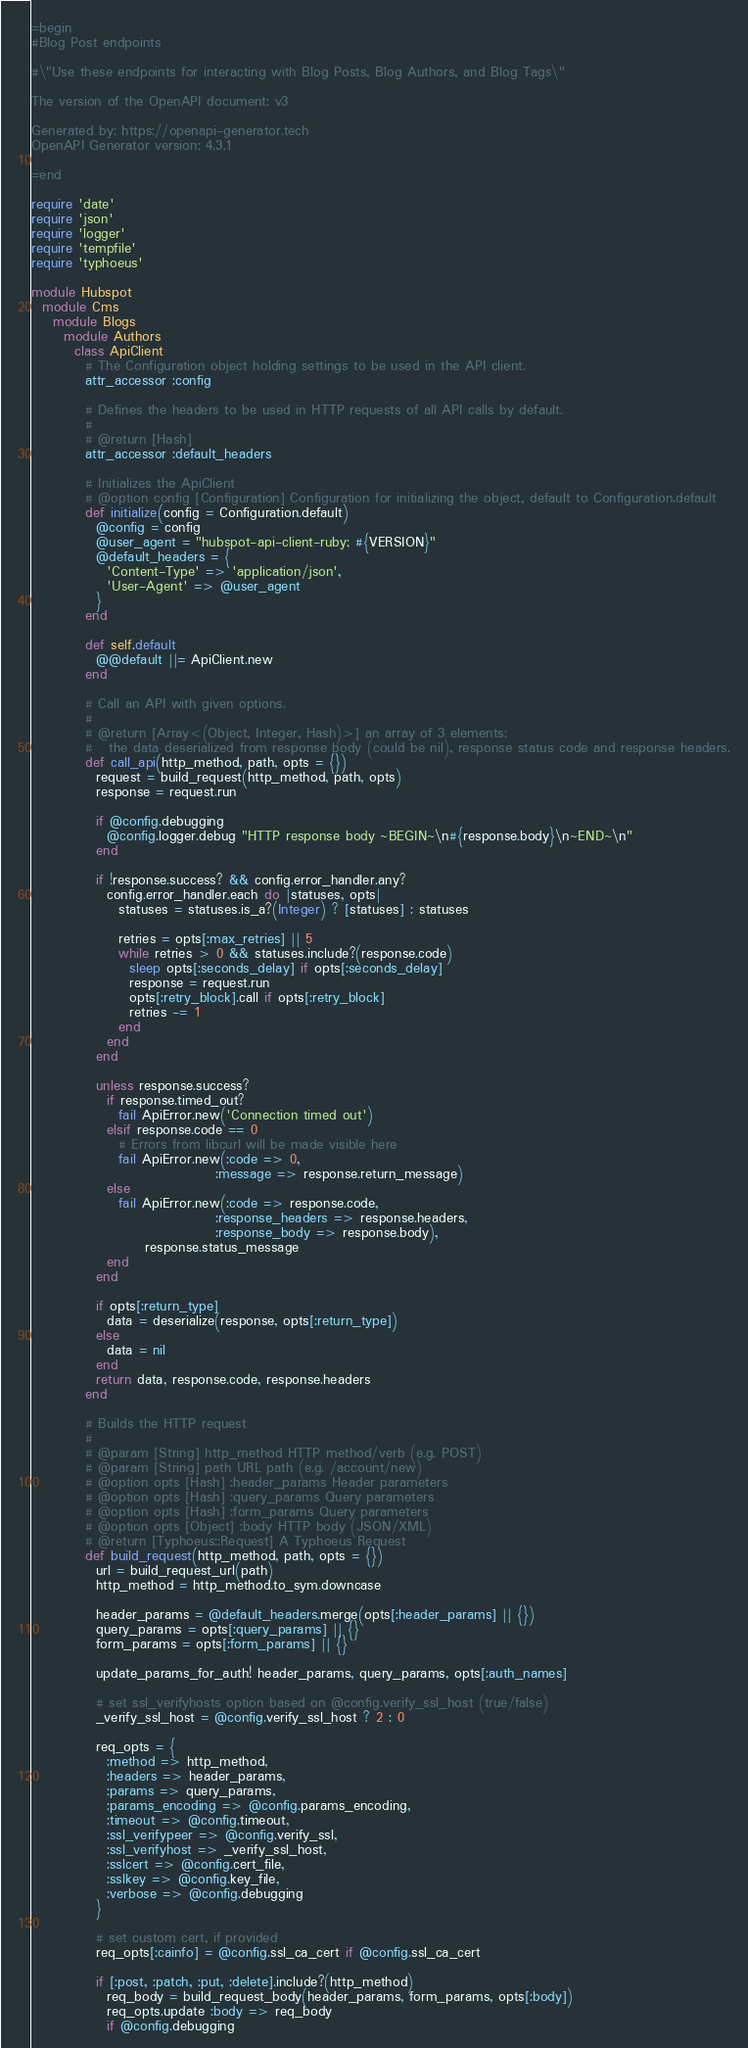<code> <loc_0><loc_0><loc_500><loc_500><_Ruby_>=begin
#Blog Post endpoints

#\"Use these endpoints for interacting with Blog Posts, Blog Authors, and Blog Tags\"

The version of the OpenAPI document: v3

Generated by: https://openapi-generator.tech
OpenAPI Generator version: 4.3.1

=end

require 'date'
require 'json'
require 'logger'
require 'tempfile'
require 'typhoeus'

module Hubspot
  module Cms
    module Blogs
      module Authors
        class ApiClient
          # The Configuration object holding settings to be used in the API client.
          attr_accessor :config

          # Defines the headers to be used in HTTP requests of all API calls by default.
          #
          # @return [Hash]
          attr_accessor :default_headers

          # Initializes the ApiClient
          # @option config [Configuration] Configuration for initializing the object, default to Configuration.default
          def initialize(config = Configuration.default)
            @config = config
            @user_agent = "hubspot-api-client-ruby; #{VERSION}"
            @default_headers = {
              'Content-Type' => 'application/json',
              'User-Agent' => @user_agent
            }
          end

          def self.default
            @@default ||= ApiClient.new
          end

          # Call an API with given options.
          #
          # @return [Array<(Object, Integer, Hash)>] an array of 3 elements:
          #   the data deserialized from response body (could be nil), response status code and response headers.
          def call_api(http_method, path, opts = {})
            request = build_request(http_method, path, opts)
            response = request.run

            if @config.debugging
              @config.logger.debug "HTTP response body ~BEGIN~\n#{response.body}\n~END~\n"
            end

            if !response.success? && config.error_handler.any?
              config.error_handler.each do |statuses, opts|
                statuses = statuses.is_a?(Integer) ? [statuses] : statuses

                retries = opts[:max_retries] || 5
                while retries > 0 && statuses.include?(response.code)
                  sleep opts[:seconds_delay] if opts[:seconds_delay]
                  response = request.run
                  opts[:retry_block].call if opts[:retry_block]
                  retries -= 1
                end
              end
            end

            unless response.success?
              if response.timed_out?
                fail ApiError.new('Connection timed out')
              elsif response.code == 0
                # Errors from libcurl will be made visible here
                fail ApiError.new(:code => 0,
                                  :message => response.return_message)
              else
                fail ApiError.new(:code => response.code,
                                  :response_headers => response.headers,
                                  :response_body => response.body),
                     response.status_message
              end
            end

            if opts[:return_type]
              data = deserialize(response, opts[:return_type])
            else
              data = nil
            end
            return data, response.code, response.headers
          end

          # Builds the HTTP request
          #
          # @param [String] http_method HTTP method/verb (e.g. POST)
          # @param [String] path URL path (e.g. /account/new)
          # @option opts [Hash] :header_params Header parameters
          # @option opts [Hash] :query_params Query parameters
          # @option opts [Hash] :form_params Query parameters
          # @option opts [Object] :body HTTP body (JSON/XML)
          # @return [Typhoeus::Request] A Typhoeus Request
          def build_request(http_method, path, opts = {})
            url = build_request_url(path)
            http_method = http_method.to_sym.downcase

            header_params = @default_headers.merge(opts[:header_params] || {})
            query_params = opts[:query_params] || {}
            form_params = opts[:form_params] || {}

            update_params_for_auth! header_params, query_params, opts[:auth_names]

            # set ssl_verifyhosts option based on @config.verify_ssl_host (true/false)
            _verify_ssl_host = @config.verify_ssl_host ? 2 : 0

            req_opts = {
              :method => http_method,
              :headers => header_params,
              :params => query_params,
              :params_encoding => @config.params_encoding,
              :timeout => @config.timeout,
              :ssl_verifypeer => @config.verify_ssl,
              :ssl_verifyhost => _verify_ssl_host,
              :sslcert => @config.cert_file,
              :sslkey => @config.key_file,
              :verbose => @config.debugging
            }

            # set custom cert, if provided
            req_opts[:cainfo] = @config.ssl_ca_cert if @config.ssl_ca_cert

            if [:post, :patch, :put, :delete].include?(http_method)
              req_body = build_request_body(header_params, form_params, opts[:body])
              req_opts.update :body => req_body
              if @config.debugging</code> 